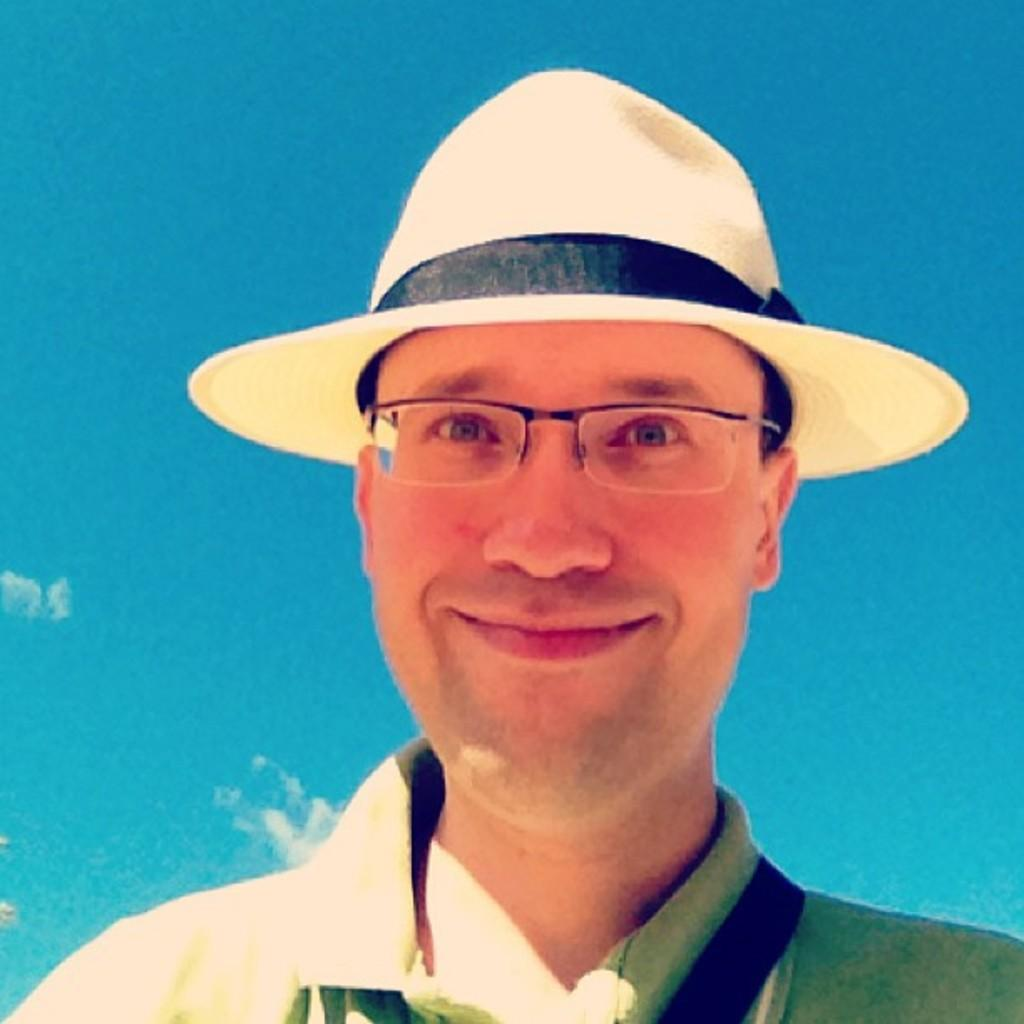Who is present in the image? There is a man in the image. What is the man doing in the image? The man is smiling in the image. What accessories is the man wearing in the image? The man is wearing spectacles and a cap in the image. What can be seen in the background of the image? There are clouds visible in the background of the image. What sound does the kitten make in the image? There is no kitten present in the image, so it is not possible to determine the sound it might make. 